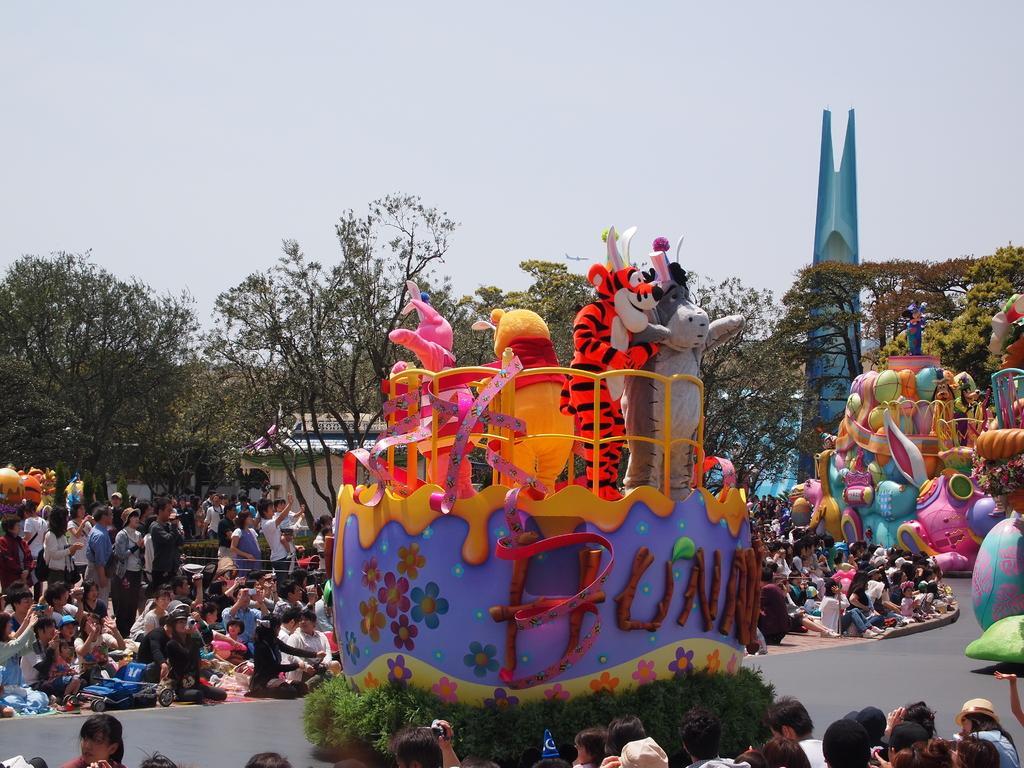In one or two sentences, can you explain what this image depicts? In this picture we can observe some people sitting on the side of the road. Some of them was standing. We can observe some toys standing behind this yellow color railing. On the right side there are some colorful toys. In the background there are trees and a sky. 